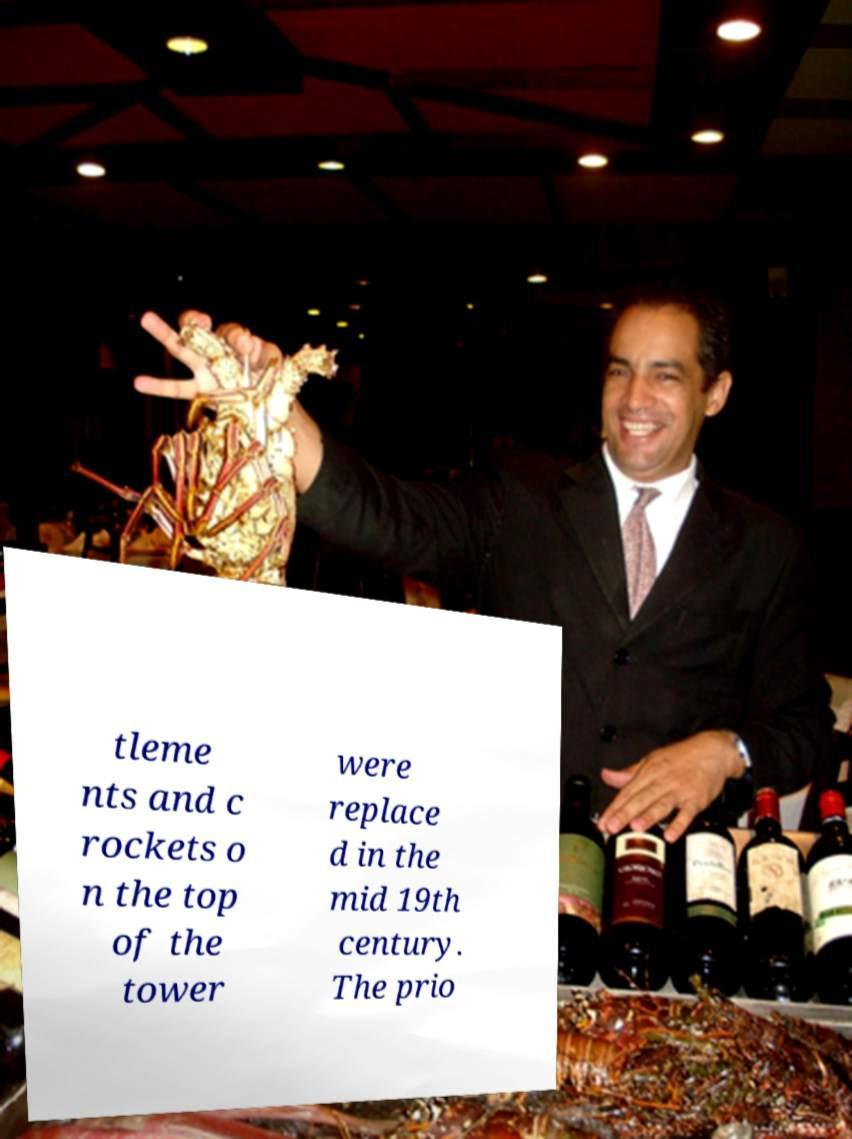I need the written content from this picture converted into text. Can you do that? tleme nts and c rockets o n the top of the tower were replace d in the mid 19th century. The prio 